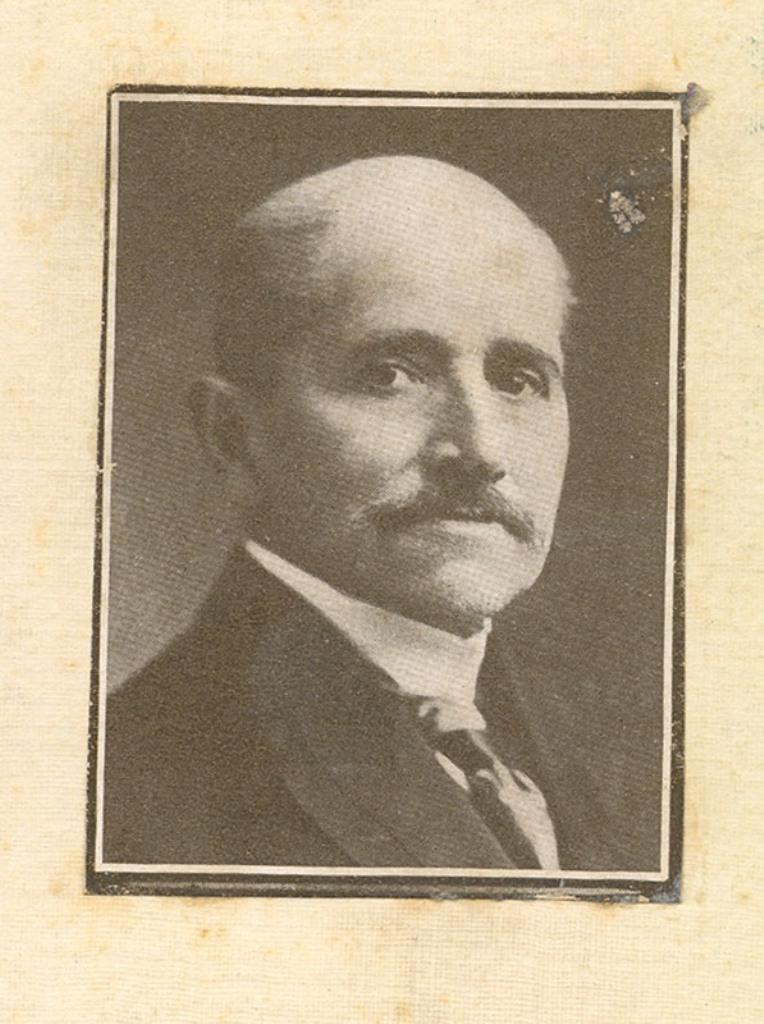What is the main subject of the image? There is a photo of a man in the image. Can you describe the background of the image? The background of the image is light in color. What type of instrument is the man playing in the image? There is no instrument present in the image, as it only features a photo of a man with a light-colored background. 